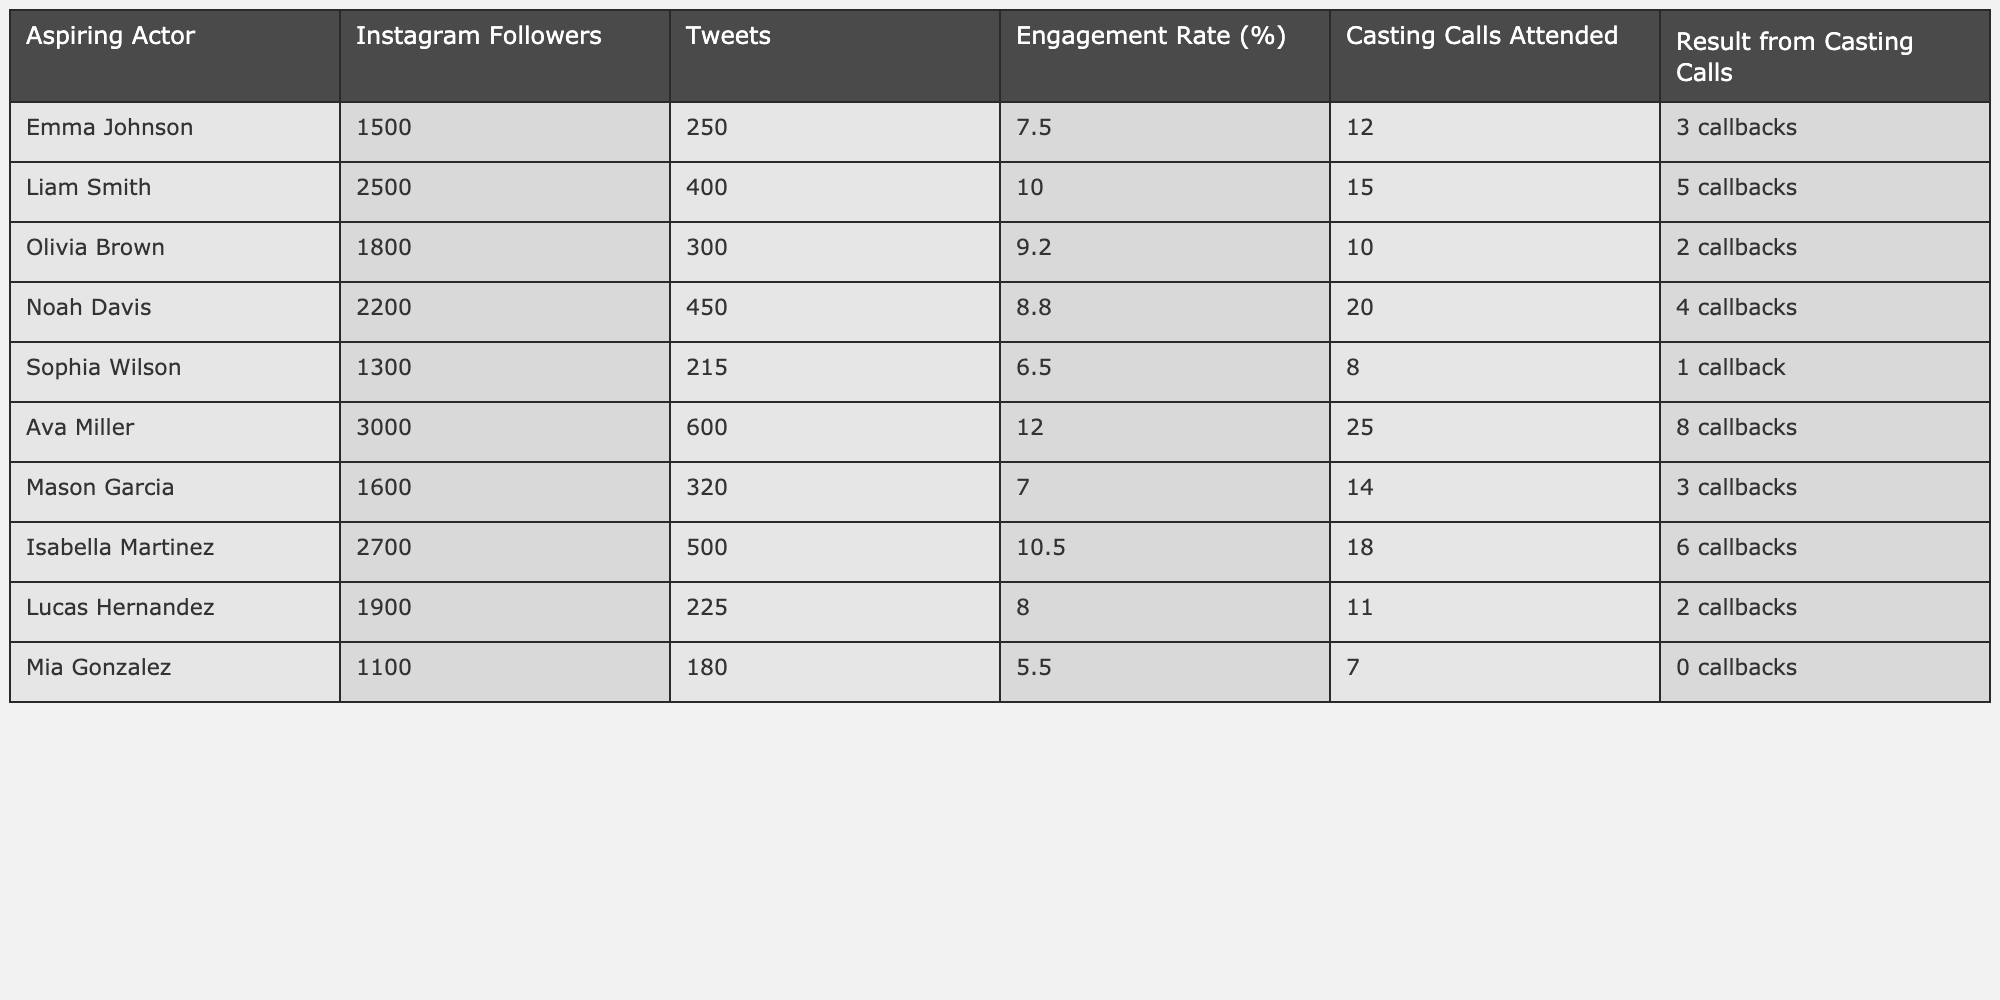What's the total number of followers for all actors in the table? To find the total number of followers, sum the Instagram followers of each actor: 1500 + 2500 + 1800 + 2200 + 1300 + 3000 + 1600 + 2700 + 1900 + 1100 = 18600.
Answer: 18600 Who has the highest engagement rate, and what is it? The highest engagement rate can be found by comparing the engagement rates of all actors. Ava Miller has the highest engagement rate of 12.0%.
Answer: Ava Miller, 12.0% How many casting calls did Mia Gonzalez attend? Mia Gonzalez's total casting calls attended is given directly in the table as 7.
Answer: 7 What is the average engagement rate of the actors listed? To find the average engagement rate, sum all engagement rates: (7.5 + 10.0 + 9.2 + 8.8 + 6.5 + 12.0 + 7.0 + 10.5 + 8.0 + 5.5 = 78.5), and then divide by the number of actors (10): 78.5 / 10 = 7.85.
Answer: 7.85 Is it true that more Instagram followers correlate to a higher number of casting calls attended? Check the relationship between the number of followers and casting calls for each actor. Ava Miller has the highest followers (3000) and attended 25 calls. Conversely, Mia Gonzalez has the lowest followers (1100) and attended only 7 calls. This suggests a positive correlation.
Answer: Yes How many callbacks did actors with an engagement rate over 10% receive in total? Identify actors with an engagement rate over 10%—Ava Miller (8 callbacks) and Isabella Martinez (6 callbacks). Add their callbacks: 8 + 6 = 14.
Answer: 14 Which actor has the lowest engagement rate, and what was their result from casting calls? The lowest engagement rate is 5.5% (Mia Gonzalez), and her result from casting calls is 0 callbacks.
Answer: Mia Gonzalez, 0 callbacks What is the difference between the highest and lowest number of casting calls attended? The highest number of casting calls attended is 25 (Ava Miller), and the lowest is 7 (Mia Gonzalez). Calculate the difference: 25 - 7 = 18.
Answer: 18 